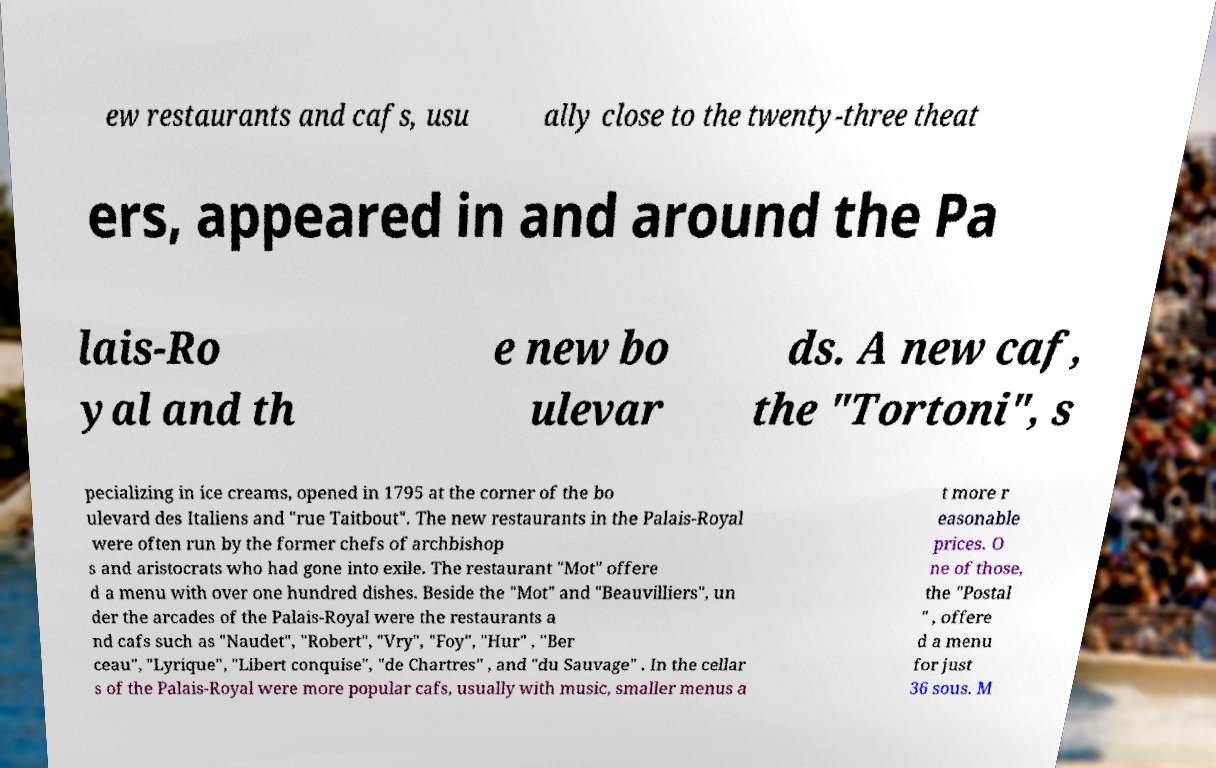Could you extract and type out the text from this image? ew restaurants and cafs, usu ally close to the twenty-three theat ers, appeared in and around the Pa lais-Ro yal and th e new bo ulevar ds. A new caf, the "Tortoni", s pecializing in ice creams, opened in 1795 at the corner of the bo ulevard des Italiens and "rue Taitbout". The new restaurants in the Palais-Royal were often run by the former chefs of archbishop s and aristocrats who had gone into exile. The restaurant "Mot" offere d a menu with over one hundred dishes. Beside the "Mot" and "Beauvilliers", un der the arcades of the Palais-Royal were the restaurants a nd cafs such as "Naudet", "Robert", "Vry", "Foy", "Hur" , "Ber ceau", "Lyrique", "Libert conquise", "de Chartres" , and "du Sauvage" . In the cellar s of the Palais-Royal were more popular cafs, usually with music, smaller menus a t more r easonable prices. O ne of those, the "Postal " , offere d a menu for just 36 sous. M 